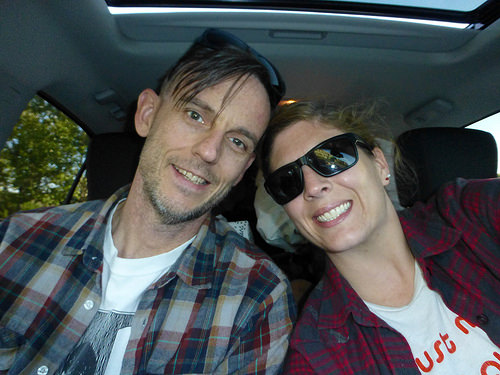<image>
Can you confirm if the girl is to the left of the boy? Yes. From this viewpoint, the girl is positioned to the left side relative to the boy. Is the man to the left of the women? No. The man is not to the left of the women. From this viewpoint, they have a different horizontal relationship. 